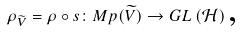Convert formula to latex. <formula><loc_0><loc_0><loc_500><loc_500>\rho _ { \widetilde { V } } = \rho \circ s \colon M p ( \widetilde { V } ) \rightarrow G L \left ( \mathcal { H } \right ) \text {,}</formula> 